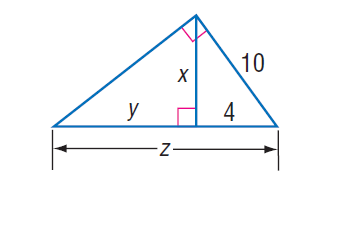Answer the mathemtical geometry problem and directly provide the correct option letter.
Question: Find x.
Choices: A: \sqrt { 7 } B: \sqrt { 21 } C: 2 \sqrt { 21 } D: 21 C 